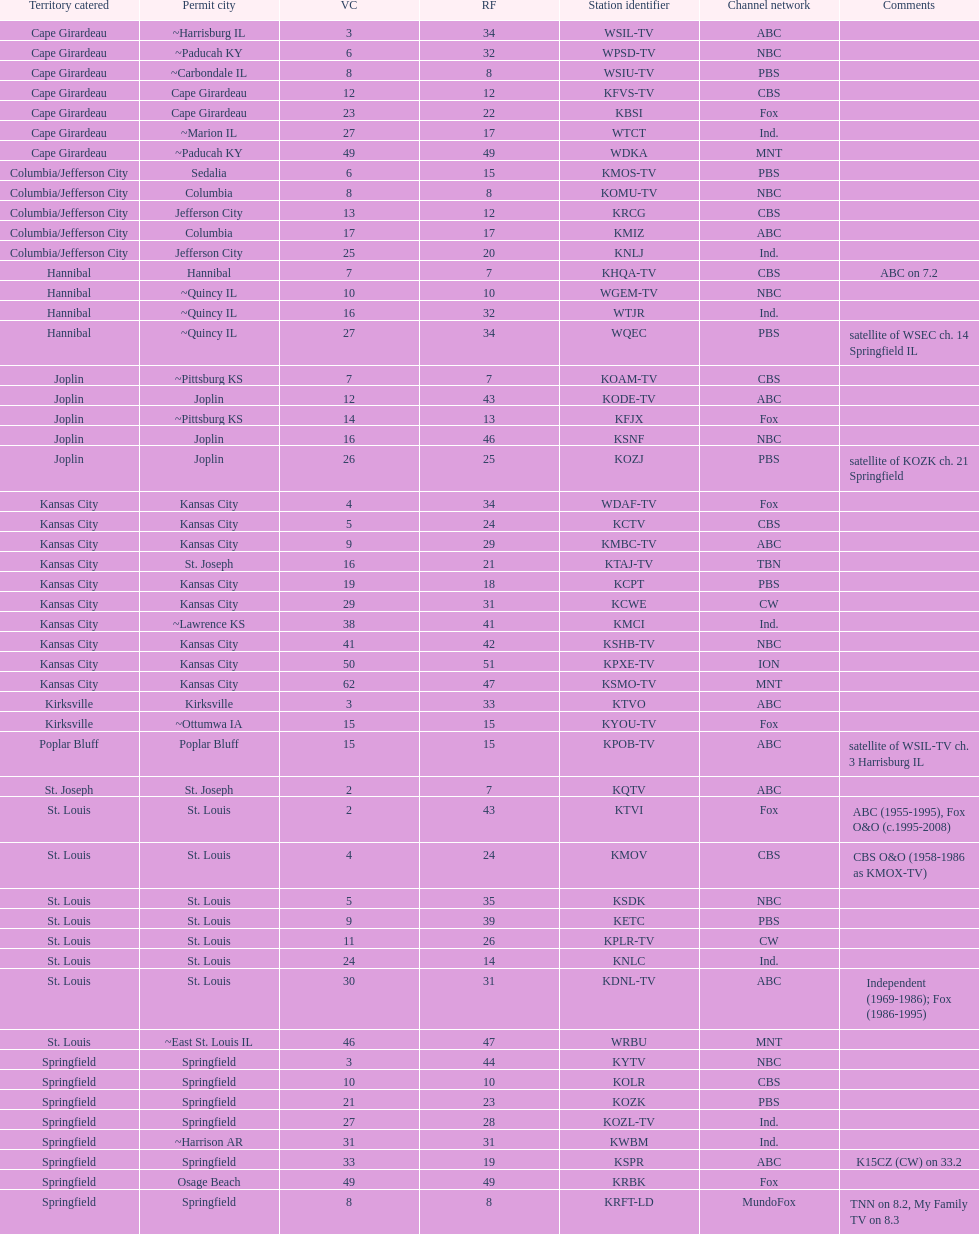How many television stations serve the cape girardeau area? 7. 